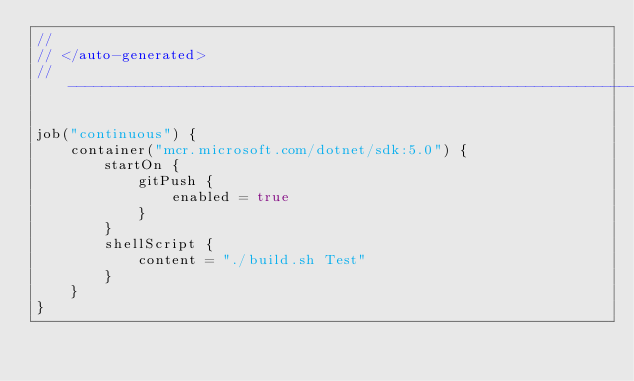<code> <loc_0><loc_0><loc_500><loc_500><_Kotlin_>//
// </auto-generated>
// ------------------------------------------------------------------------------

job("continuous") {
    container("mcr.microsoft.com/dotnet/sdk:5.0") {
        startOn {
            gitPush {
                enabled = true
            }
        }
        shellScript {
            content = "./build.sh Test"
        }
    }
}
</code> 